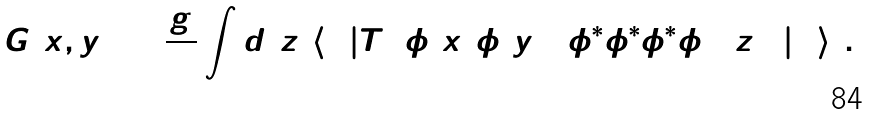<formula> <loc_0><loc_0><loc_500><loc_500>G ( x , y ) = \frac { g } { 4 ! } \int d ^ { 4 } z \, \left \langle 0 \left | T \left ( \phi ( x ) \phi ( y ) \left ( \phi ^ { * } \phi ^ { * } \phi ^ { * } \phi \right ) ( z ) \right ) \right | 0 \right \rangle \, .</formula> 